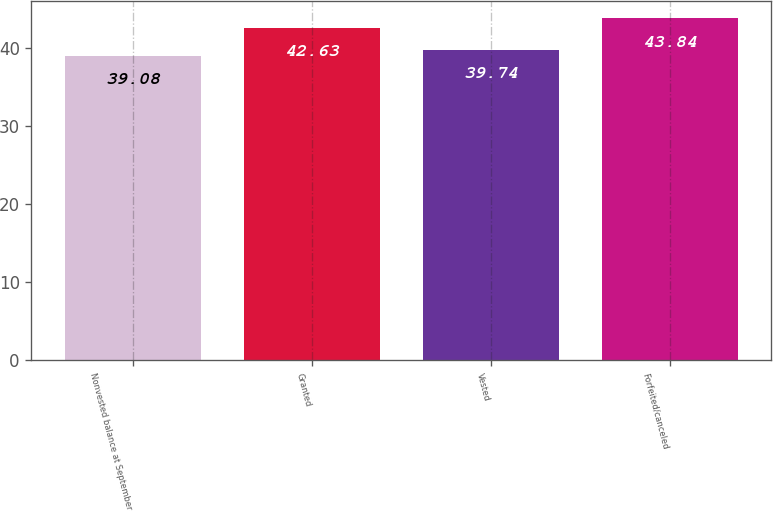Convert chart. <chart><loc_0><loc_0><loc_500><loc_500><bar_chart><fcel>Nonvested balance at September<fcel>Granted<fcel>Vested<fcel>Forfeited/canceled<nl><fcel>39.08<fcel>42.63<fcel>39.74<fcel>43.84<nl></chart> 